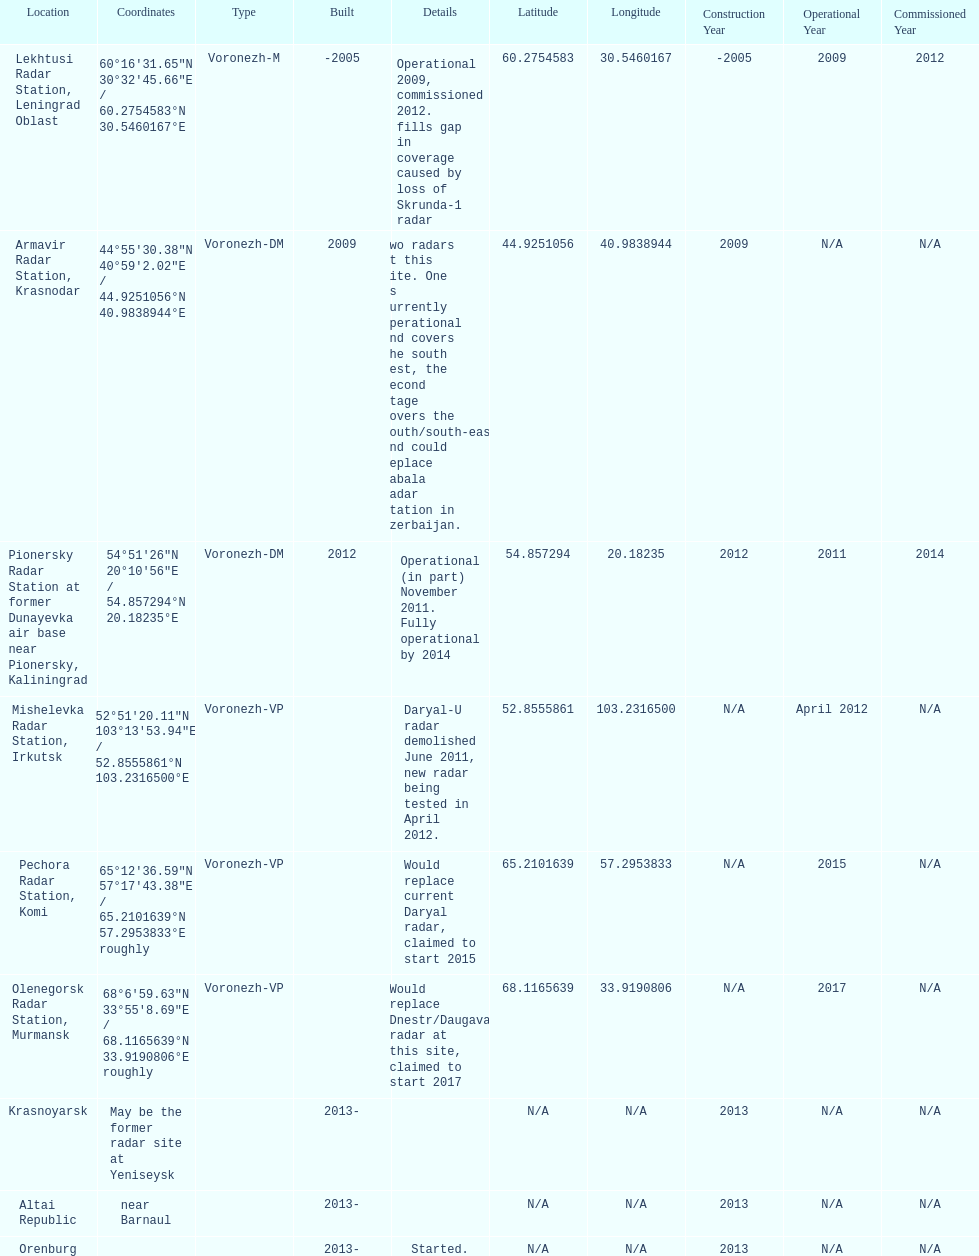What is the only radar that will start in 2015? Pechora Radar Station, Komi. 